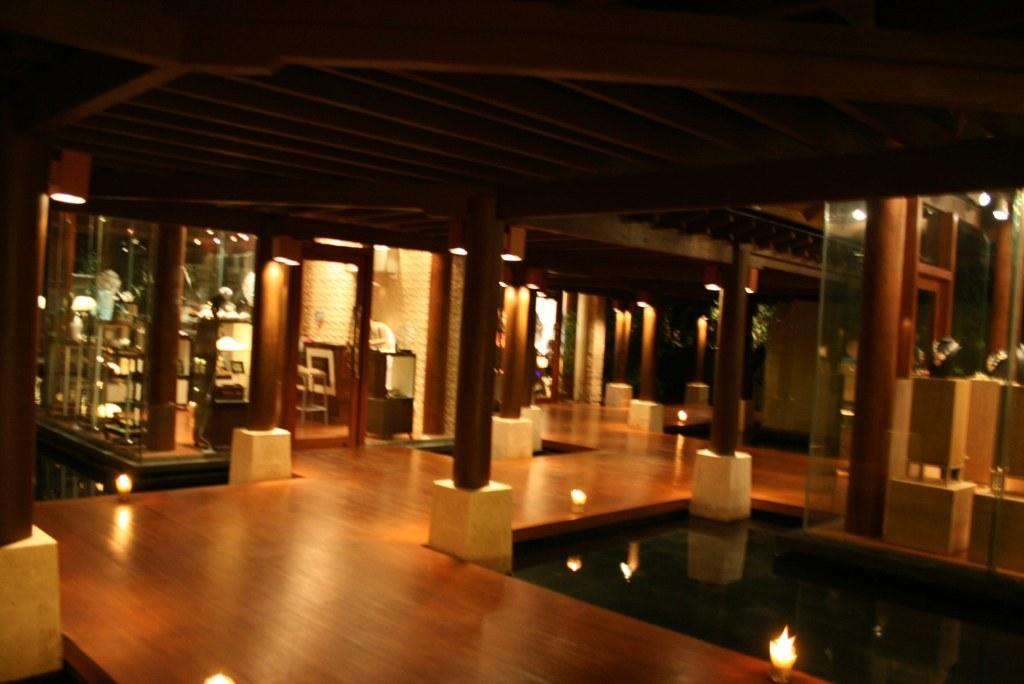What type of structure is shown in the image? The image shows an inner view of a house. What is the uppermost part of the house called? The house has a roof. What architectural elements support the structure of the house? There are pillars in the house. What type of doors are present in the house? The house has glass doors. What is the surface on which people walk inside the house? The house has a floor. What encloses the interior space of the house? The house has walls. What recreational feature is present inside the house? There is a swimming pool in the house. How many letters can be seen on the fingers of the person in the image? There is no person present in the image, and therefore no fingers or letters can be observed. 